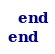Convert code to text. <code><loc_0><loc_0><loc_500><loc_500><_Ruby_>  end
end
</code> 